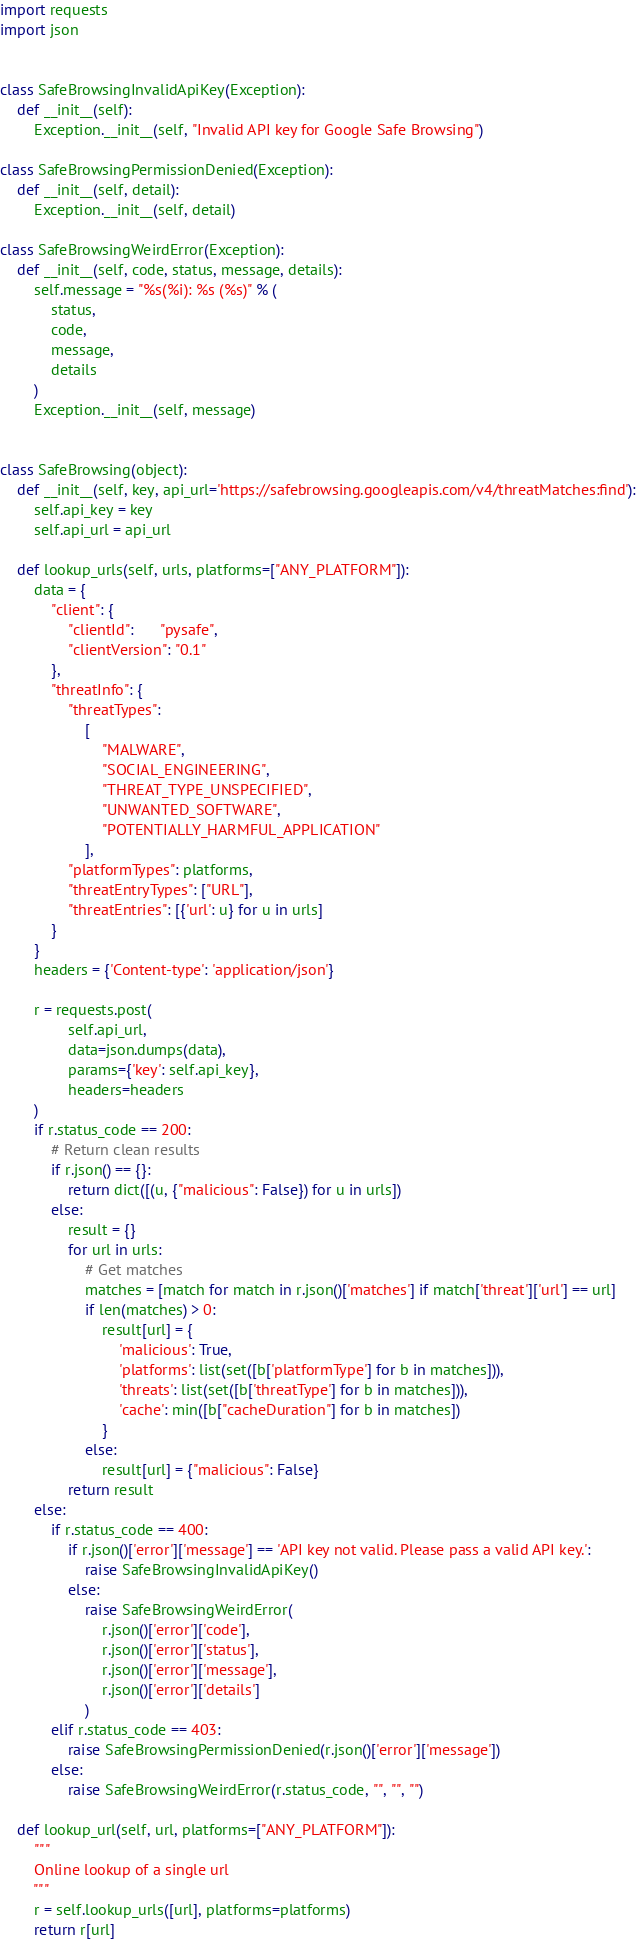Convert code to text. <code><loc_0><loc_0><loc_500><loc_500><_Python_>import requests
import json


class SafeBrowsingInvalidApiKey(Exception):
    def __init__(self):
        Exception.__init__(self, "Invalid API key for Google Safe Browsing")

class SafeBrowsingPermissionDenied(Exception):
    def __init__(self, detail):
        Exception.__init__(self, detail)

class SafeBrowsingWeirdError(Exception):
    def __init__(self, code, status, message, details):
        self.message = "%s(%i): %s (%s)" % (
            status,
            code,
            message,
            details
        )
        Exception.__init__(self, message)


class SafeBrowsing(object):
    def __init__(self, key, api_url='https://safebrowsing.googleapis.com/v4/threatMatches:find'):
        self.api_key = key
        self.api_url = api_url

    def lookup_urls(self, urls, platforms=["ANY_PLATFORM"]):
        data = {
            "client": {
                "clientId":      "pysafe",
                "clientVersion": "0.1"
            },
            "threatInfo": {
                "threatTypes":
                    [
                        "MALWARE",
                        "SOCIAL_ENGINEERING",
                        "THREAT_TYPE_UNSPECIFIED",
                        "UNWANTED_SOFTWARE",
                        "POTENTIALLY_HARMFUL_APPLICATION"
                    ],
                "platformTypes": platforms,
                "threatEntryTypes": ["URL"],
                "threatEntries": [{'url': u} for u in urls]
            }
        }
        headers = {'Content-type': 'application/json'}

        r = requests.post(
                self.api_url,
                data=json.dumps(data),
                params={'key': self.api_key},
                headers=headers
        )
        if r.status_code == 200:
            # Return clean results
            if r.json() == {}:
                return dict([(u, {"malicious": False}) for u in urls])
            else:
                result = {}
                for url in urls:
                    # Get matches
                    matches = [match for match in r.json()['matches'] if match['threat']['url'] == url]
                    if len(matches) > 0:
                        result[url] = {
                            'malicious': True,
                            'platforms': list(set([b['platformType'] for b in matches])),
                            'threats': list(set([b['threatType'] for b in matches])),
                            'cache': min([b["cacheDuration"] for b in matches])
                        }
                    else:
                        result[url] = {"malicious": False}
                return result
        else:
            if r.status_code == 400:
                if r.json()['error']['message'] == 'API key not valid. Please pass a valid API key.':
                    raise SafeBrowsingInvalidApiKey()
                else:
                    raise SafeBrowsingWeirdError(
                        r.json()['error']['code'],
                        r.json()['error']['status'],
                        r.json()['error']['message'],
                        r.json()['error']['details']
                    )
            elif r.status_code == 403:
                raise SafeBrowsingPermissionDenied(r.json()['error']['message'])
            else:
                raise SafeBrowsingWeirdError(r.status_code, "", "", "")

    def lookup_url(self, url, platforms=["ANY_PLATFORM"]):
        """
        Online lookup of a single url
        """
        r = self.lookup_urls([url], platforms=platforms)
        return r[url]
</code> 